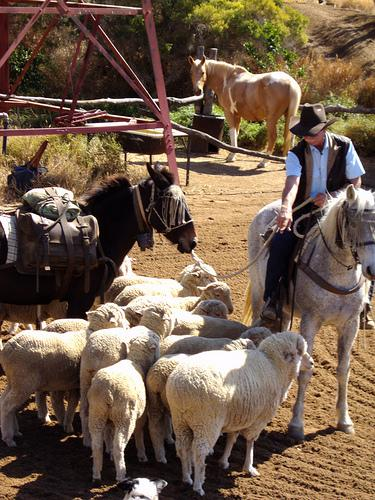Question: where is this picture taken?
Choices:
A. In the country.
B. In the city.
C. Downtown.
D. In the desert.
Answer with the letter. Answer: A Question: who is riding the horse?
Choices:
A. A man.
B. A woman.
C. A boy.
D. A girl.
Answer with the letter. Answer: A Question: how many horses are there?
Choices:
A. Four.
B. Five.
C. Six.
D. Three.
Answer with the letter. Answer: D Question: what color shirt is the man wearing?
Choices:
A. Red.
B. Blue.
C. Yellow.
D. Green.
Answer with the letter. Answer: B Question: where are they standing?
Choices:
A. On the grass.
B. In the pool.
C. On the driveway.
D. In the dirt.
Answer with the letter. Answer: D 